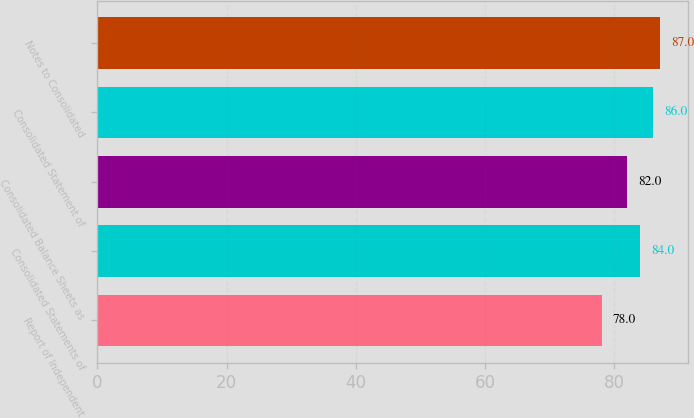Convert chart to OTSL. <chart><loc_0><loc_0><loc_500><loc_500><bar_chart><fcel>Report of Independent<fcel>Consolidated Statements of<fcel>Consolidated Balance Sheets as<fcel>Consolidated Statement of<fcel>Notes to Consolidated<nl><fcel>78<fcel>84<fcel>82<fcel>86<fcel>87<nl></chart> 